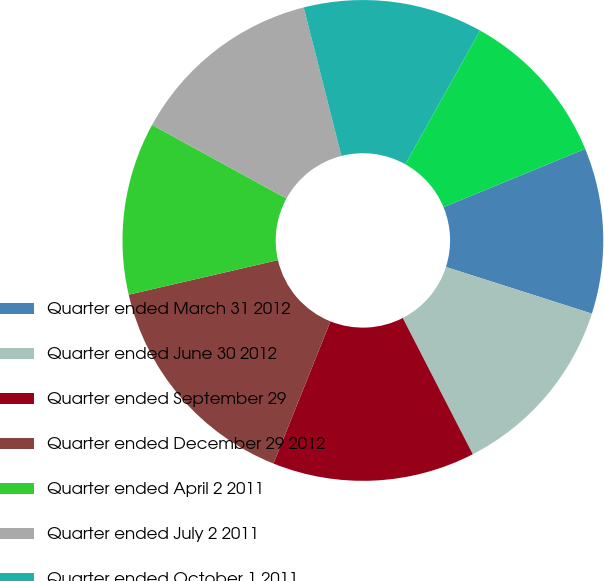Convert chart. <chart><loc_0><loc_0><loc_500><loc_500><pie_chart><fcel>Quarter ended March 31 2012<fcel>Quarter ended June 30 2012<fcel>Quarter ended September 29<fcel>Quarter ended December 29 2012<fcel>Quarter ended April 2 2011<fcel>Quarter ended July 2 2011<fcel>Quarter ended October 1 2011<fcel>Quarter ended December 31 2011<nl><fcel>11.14%<fcel>12.52%<fcel>13.62%<fcel>15.31%<fcel>11.6%<fcel>13.06%<fcel>12.06%<fcel>10.68%<nl></chart> 